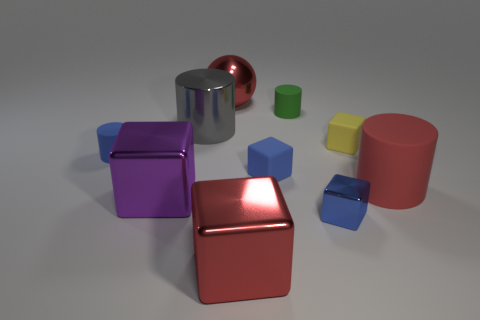Are there any other things of the same color as the big metal sphere?
Make the answer very short. Yes. What number of objects are big shiny things that are in front of the large red rubber object or large spheres?
Your answer should be compact. 3. Is the color of the large rubber cylinder the same as the metal ball?
Provide a short and direct response. Yes. What number of other objects are there of the same shape as the blue metallic thing?
Your answer should be compact. 4. How many cyan objects are either rubber things or small metal blocks?
Offer a terse response. 0. What color is the large object that is made of the same material as the small yellow cube?
Provide a short and direct response. Red. Are the gray cylinder in front of the green rubber thing and the green cylinder behind the purple block made of the same material?
Your response must be concise. No. What size is the matte cube that is the same color as the small shiny thing?
Make the answer very short. Small. There is a large ball that is on the right side of the big purple shiny block; what is its material?
Make the answer very short. Metal. Is the shape of the tiny blue object in front of the large purple metallic thing the same as the small yellow thing that is behind the blue matte block?
Offer a terse response. Yes. 